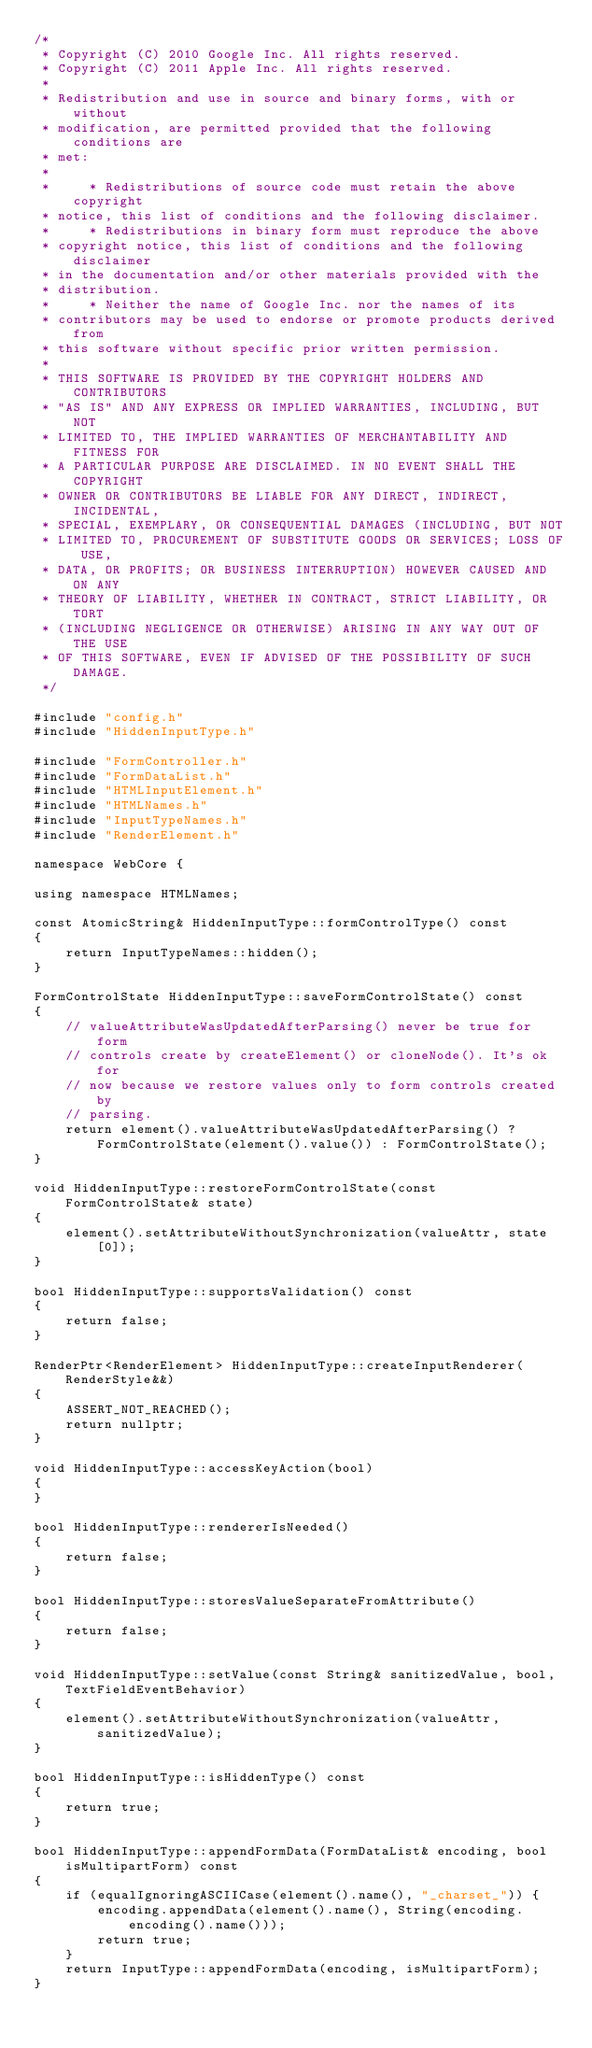Convert code to text. <code><loc_0><loc_0><loc_500><loc_500><_C++_>/*
 * Copyright (C) 2010 Google Inc. All rights reserved.
 * Copyright (C) 2011 Apple Inc. All rights reserved.
 *
 * Redistribution and use in source and binary forms, with or without
 * modification, are permitted provided that the following conditions are
 * met:
 *
 *     * Redistributions of source code must retain the above copyright
 * notice, this list of conditions and the following disclaimer.
 *     * Redistributions in binary form must reproduce the above
 * copyright notice, this list of conditions and the following disclaimer
 * in the documentation and/or other materials provided with the
 * distribution.
 *     * Neither the name of Google Inc. nor the names of its
 * contributors may be used to endorse or promote products derived from
 * this software without specific prior written permission.
 *
 * THIS SOFTWARE IS PROVIDED BY THE COPYRIGHT HOLDERS AND CONTRIBUTORS
 * "AS IS" AND ANY EXPRESS OR IMPLIED WARRANTIES, INCLUDING, BUT NOT
 * LIMITED TO, THE IMPLIED WARRANTIES OF MERCHANTABILITY AND FITNESS FOR
 * A PARTICULAR PURPOSE ARE DISCLAIMED. IN NO EVENT SHALL THE COPYRIGHT
 * OWNER OR CONTRIBUTORS BE LIABLE FOR ANY DIRECT, INDIRECT, INCIDENTAL,
 * SPECIAL, EXEMPLARY, OR CONSEQUENTIAL DAMAGES (INCLUDING, BUT NOT
 * LIMITED TO, PROCUREMENT OF SUBSTITUTE GOODS OR SERVICES; LOSS OF USE,
 * DATA, OR PROFITS; OR BUSINESS INTERRUPTION) HOWEVER CAUSED AND ON ANY
 * THEORY OF LIABILITY, WHETHER IN CONTRACT, STRICT LIABILITY, OR TORT
 * (INCLUDING NEGLIGENCE OR OTHERWISE) ARISING IN ANY WAY OUT OF THE USE
 * OF THIS SOFTWARE, EVEN IF ADVISED OF THE POSSIBILITY OF SUCH DAMAGE.
 */

#include "config.h"
#include "HiddenInputType.h"

#include "FormController.h"
#include "FormDataList.h"
#include "HTMLInputElement.h"
#include "HTMLNames.h"
#include "InputTypeNames.h"
#include "RenderElement.h"

namespace WebCore {

using namespace HTMLNames;

const AtomicString& HiddenInputType::formControlType() const
{
    return InputTypeNames::hidden();
}

FormControlState HiddenInputType::saveFormControlState() const
{
    // valueAttributeWasUpdatedAfterParsing() never be true for form
    // controls create by createElement() or cloneNode(). It's ok for
    // now because we restore values only to form controls created by
    // parsing.
    return element().valueAttributeWasUpdatedAfterParsing() ? FormControlState(element().value()) : FormControlState();
}

void HiddenInputType::restoreFormControlState(const FormControlState& state)
{
    element().setAttributeWithoutSynchronization(valueAttr, state[0]);
}

bool HiddenInputType::supportsValidation() const
{
    return false;
}

RenderPtr<RenderElement> HiddenInputType::createInputRenderer(RenderStyle&&)
{
    ASSERT_NOT_REACHED();
    return nullptr;
}

void HiddenInputType::accessKeyAction(bool)
{
}

bool HiddenInputType::rendererIsNeeded()
{
    return false;
}

bool HiddenInputType::storesValueSeparateFromAttribute()
{
    return false;
}

void HiddenInputType::setValue(const String& sanitizedValue, bool, TextFieldEventBehavior)
{
    element().setAttributeWithoutSynchronization(valueAttr, sanitizedValue);
}

bool HiddenInputType::isHiddenType() const
{
    return true;
}

bool HiddenInputType::appendFormData(FormDataList& encoding, bool isMultipartForm) const
{
    if (equalIgnoringASCIICase(element().name(), "_charset_")) {
        encoding.appendData(element().name(), String(encoding.encoding().name()));
        return true;
    }
    return InputType::appendFormData(encoding, isMultipartForm);
}
</code> 